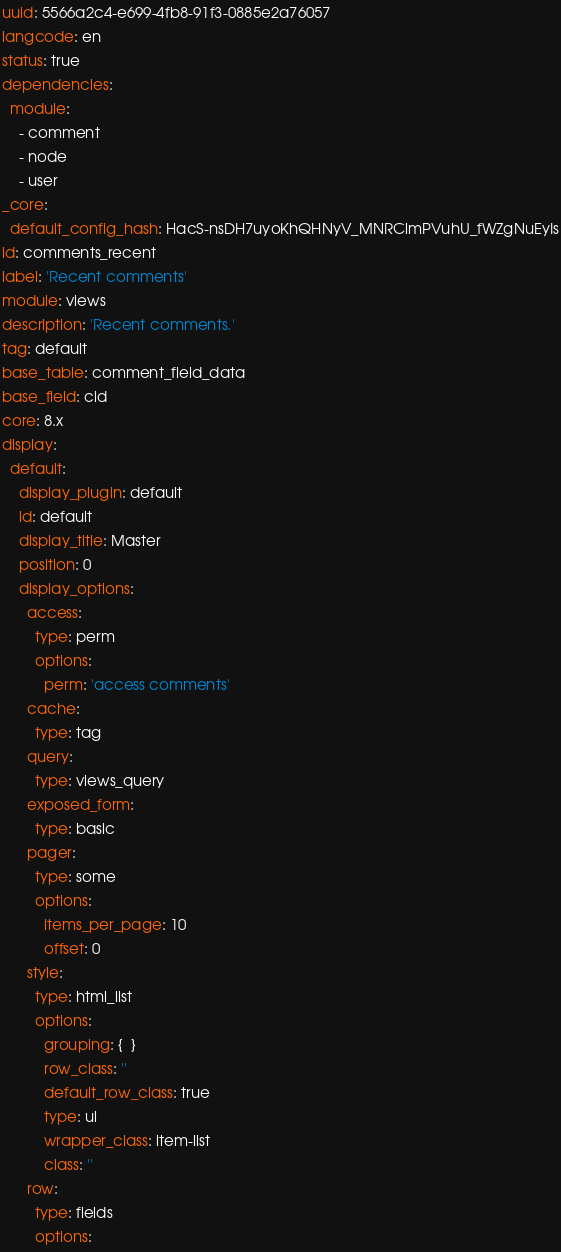Convert code to text. <code><loc_0><loc_0><loc_500><loc_500><_YAML_>uuid: 5566a2c4-e699-4fb8-91f3-0885e2a76057
langcode: en
status: true
dependencies:
  module:
    - comment
    - node
    - user
_core:
  default_config_hash: HacS-nsDH7uyoKhQHNyV_MNRClmPVuhU_fWZgNuEyIs
id: comments_recent
label: 'Recent comments'
module: views
description: 'Recent comments.'
tag: default
base_table: comment_field_data
base_field: cid
core: 8.x
display:
  default:
    display_plugin: default
    id: default
    display_title: Master
    position: 0
    display_options:
      access:
        type: perm
        options:
          perm: 'access comments'
      cache:
        type: tag
      query:
        type: views_query
      exposed_form:
        type: basic
      pager:
        type: some
        options:
          items_per_page: 10
          offset: 0
      style:
        type: html_list
        options:
          grouping: {  }
          row_class: ''
          default_row_class: true
          type: ul
          wrapper_class: item-list
          class: ''
      row:
        type: fields
        options:</code> 